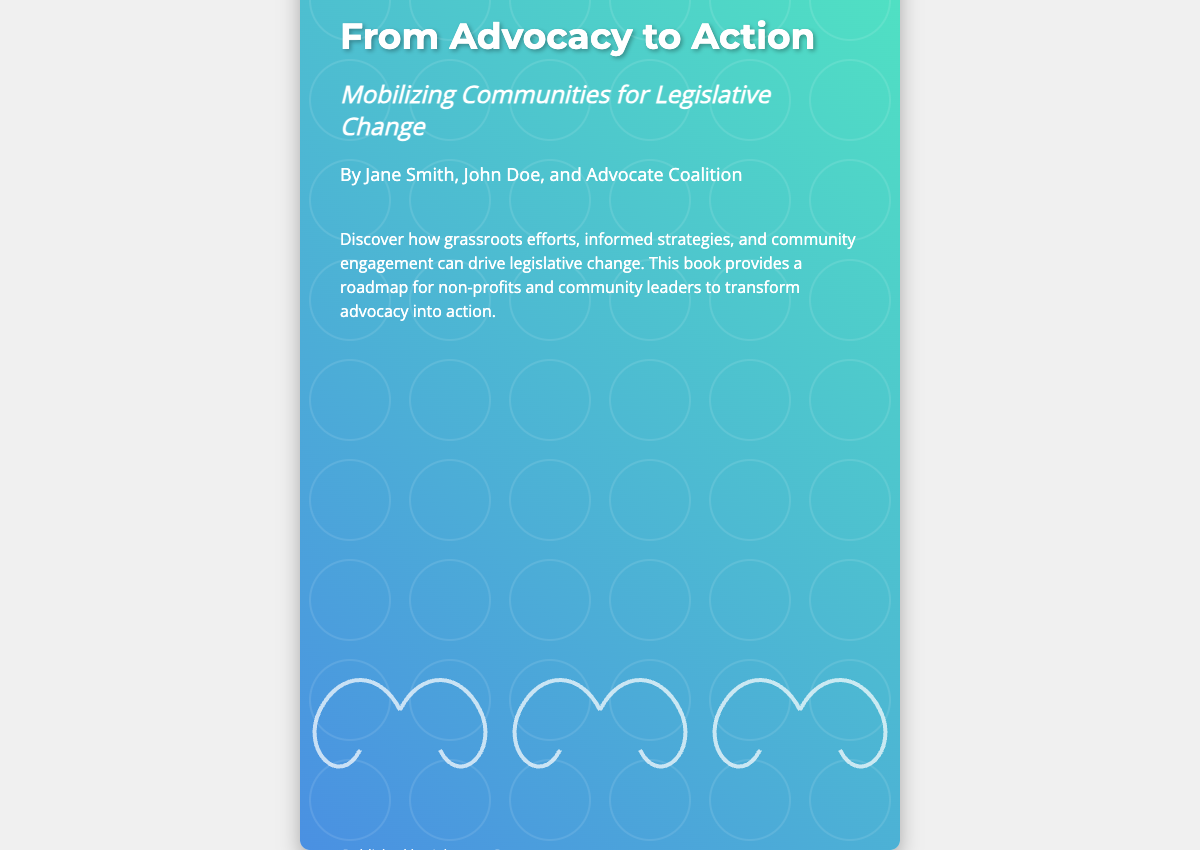What is the title of the book? The title of the book is prominently displayed on the cover.
Answer: From Advocacy to Action Who are the authors of the book? The authors' names are listed below the title in the content area.
Answer: Jane Smith, John Doe, and Advocate Coalition What is the subtitle of the book? The subtitle is located right under the title and expands on the book's theme.
Answer: Mobilizing Communities for Legislative Change What is the name of the publisher? The publisher's name is mentioned towards the bottom of the content section.
Answer: Advocacy Press What is the ISBN number? The ISBN is displayed near the publisher information.
Answer: 978-1-23456-789-0 What is the main theme of the book? The description summarizes the book's main focus on advocacy and community engagement.
Answer: Legislative change What color gradient is used in the background? The book cover features a colorful gradient from one color to another.
Answer: Blue to green What visual element symbolizes collective efforts? The cover features a specific design that illustrates collaboration.
Answer: Interconnected hands How many authors contributed to this book? The authors' section lists the total number of contributors.
Answer: Three 